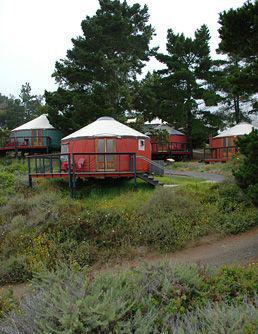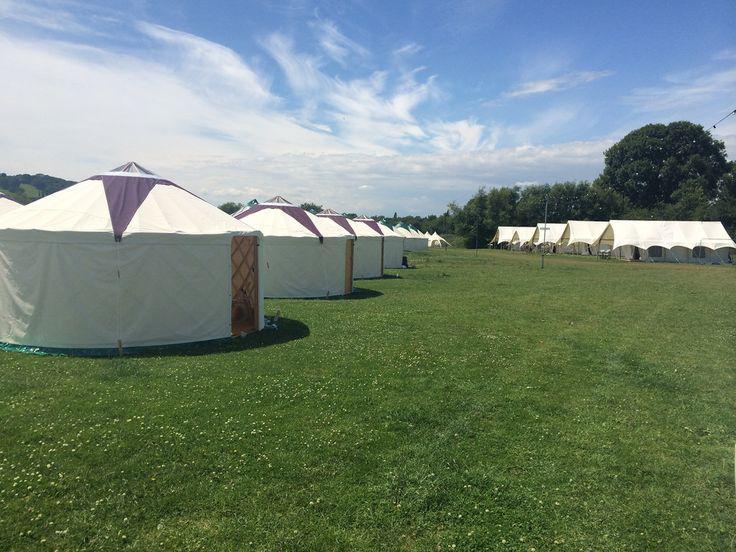The first image is the image on the left, the second image is the image on the right. For the images displayed, is the sentence "the huts are not all white but have color" factually correct? Answer yes or no. Yes. The first image is the image on the left, the second image is the image on the right. Given the left and right images, does the statement "At least one image contains 3 or more yurts." hold true? Answer yes or no. Yes. 